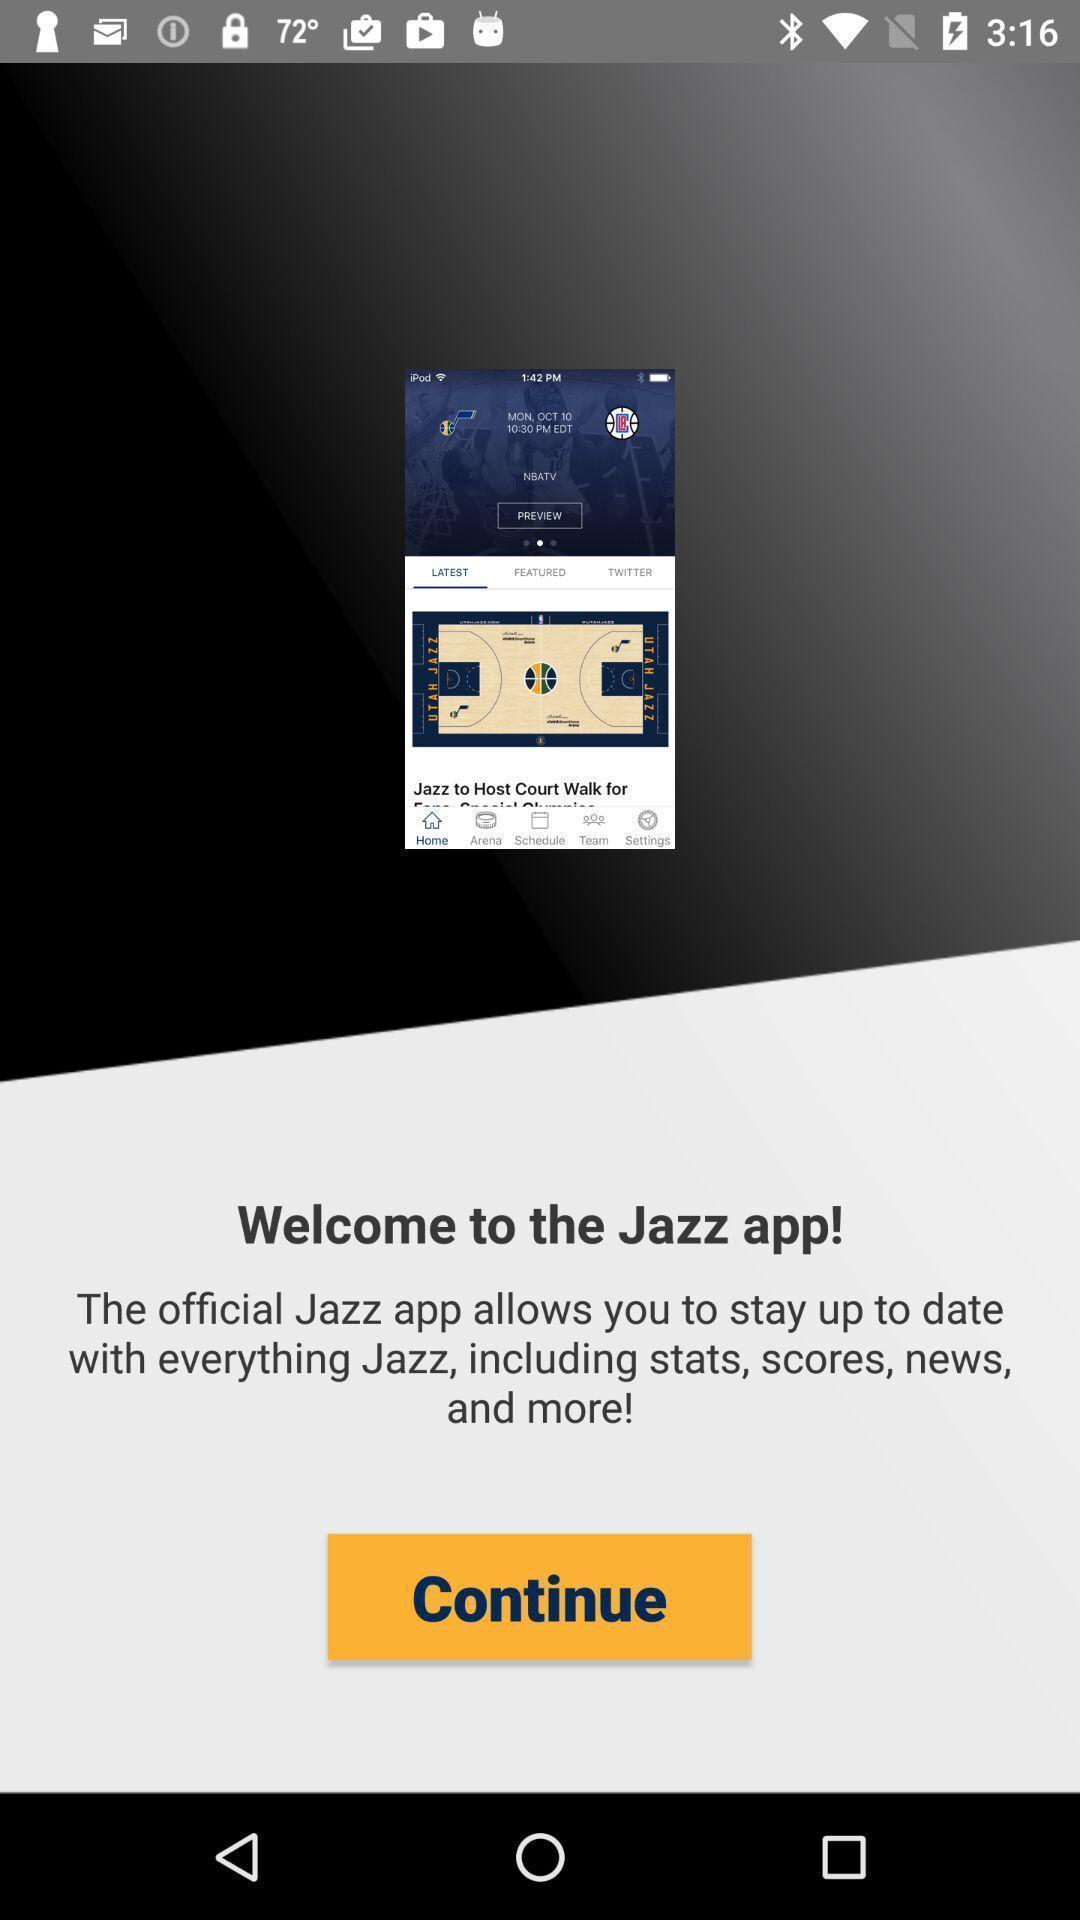Tell me about the visual elements in this screen capture. Welcome page. 